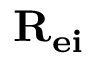<formula> <loc_0><loc_0><loc_500><loc_500>{ R _ { e i } }</formula> 